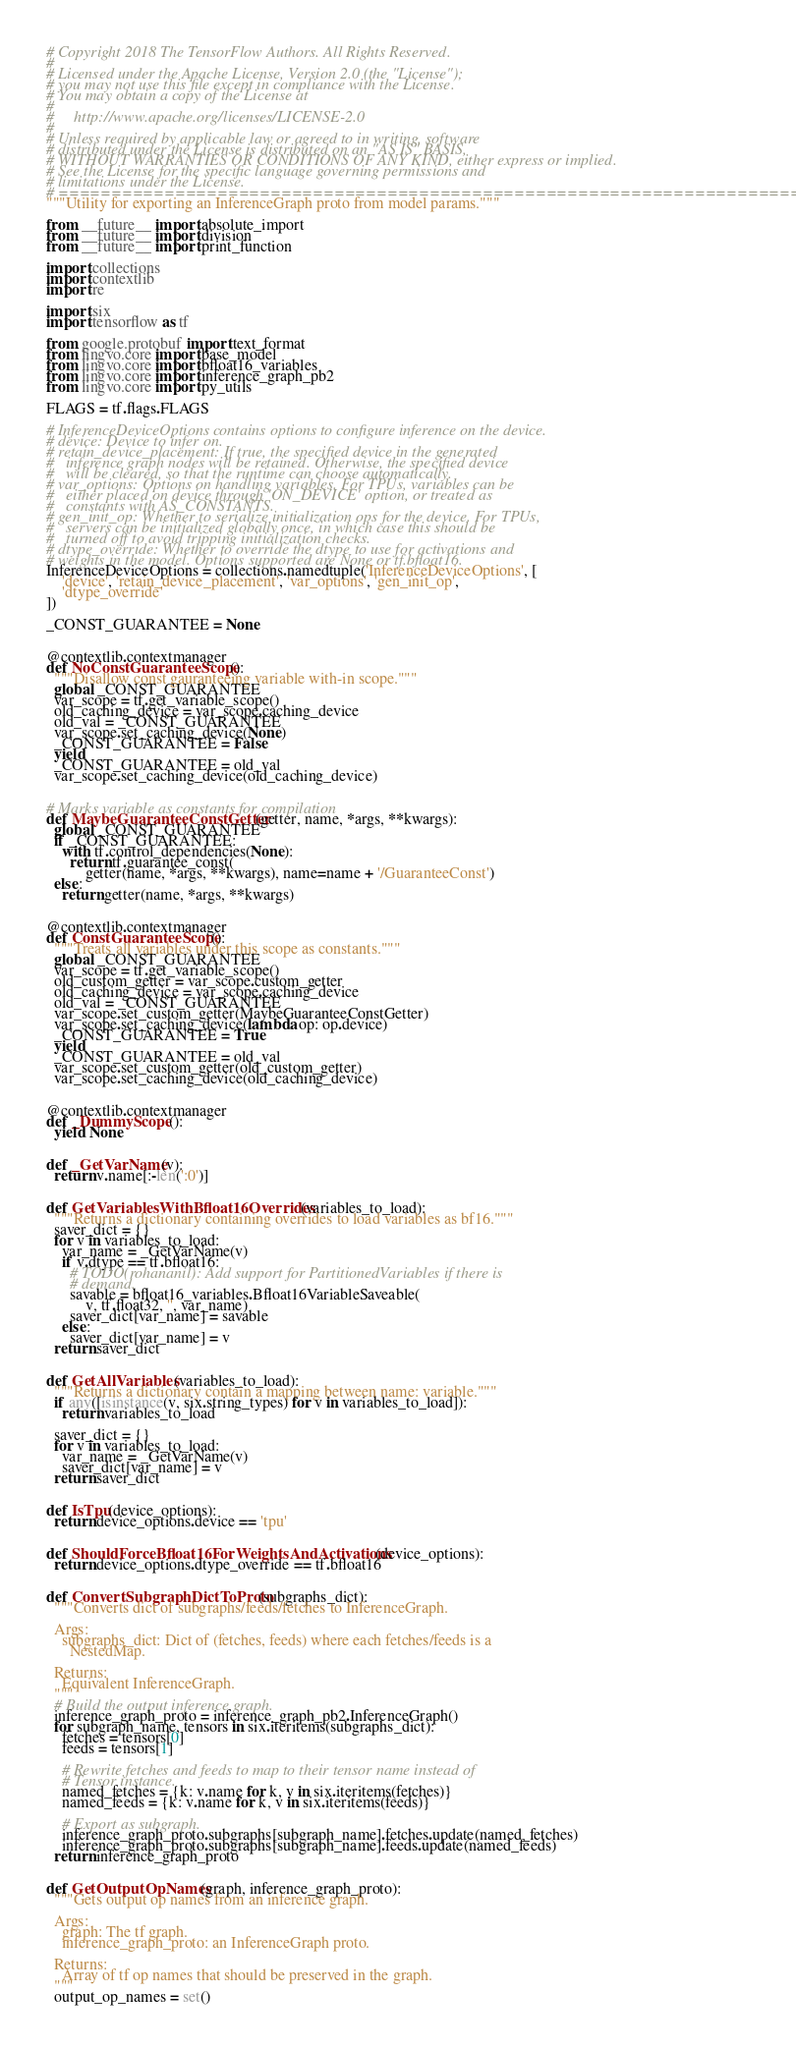<code> <loc_0><loc_0><loc_500><loc_500><_Python_># Copyright 2018 The TensorFlow Authors. All Rights Reserved.
#
# Licensed under the Apache License, Version 2.0 (the "License");
# you may not use this file except in compliance with the License.
# You may obtain a copy of the License at
#
#     http://www.apache.org/licenses/LICENSE-2.0
#
# Unless required by applicable law or agreed to in writing, software
# distributed under the License is distributed on an "AS IS" BASIS,
# WITHOUT WARRANTIES OR CONDITIONS OF ANY KIND, either express or implied.
# See the License for the specific language governing permissions and
# limitations under the License.
# ==============================================================================
"""Utility for exporting an InferenceGraph proto from model params."""

from __future__ import absolute_import
from __future__ import division
from __future__ import print_function

import collections
import contextlib
import re

import six
import tensorflow as tf

from google.protobuf import text_format
from lingvo.core import base_model
from lingvo.core import bfloat16_variables
from lingvo.core import inference_graph_pb2
from lingvo.core import py_utils

FLAGS = tf.flags.FLAGS

# InferenceDeviceOptions contains options to configure inference on the device.
# device: Device to infer on.
# retain_device_placement: If true, the specified device in the generated
#   inference graph nodes will be retained. Otherwise, the specified device
#   will be cleared, so that the runtime can choose automatically.
# var_options: Options on handling variables. For TPUs, variables can be
#   either placed on device through 'ON_DEVICE' option, or treated as
#   constants with AS_CONSTANTS.
# gen_init_op: Whether to serialize initialization ops for the device. For TPUs,
#   servers can be initialized globally once, in which case this should be
#   turned off to avoid tripping initialization checks.
# dtype_override: Whether to override the dtype to use for activations and
# weights in the model. Options supported are None or tf.bfloat16.
InferenceDeviceOptions = collections.namedtuple('InferenceDeviceOptions', [
    'device', 'retain_device_placement', 'var_options', 'gen_init_op',
    'dtype_override'
])

_CONST_GUARANTEE = None


@contextlib.contextmanager
def NoConstGuaranteeScope():
  """Disallow const gauranteeing variable with-in scope."""
  global _CONST_GUARANTEE
  var_scope = tf.get_variable_scope()
  old_caching_device = var_scope.caching_device
  old_val = _CONST_GUARANTEE
  var_scope.set_caching_device(None)
  _CONST_GUARANTEE = False
  yield
  _CONST_GUARANTEE = old_val
  var_scope.set_caching_device(old_caching_device)


# Marks variable as constants for compilation
def MaybeGuaranteeConstGetter(getter, name, *args, **kwargs):
  global _CONST_GUARANTEE
  if _CONST_GUARANTEE:
    with tf.control_dependencies(None):
      return tf.guarantee_const(
          getter(name, *args, **kwargs), name=name + '/GuaranteeConst')
  else:
    return getter(name, *args, **kwargs)


@contextlib.contextmanager
def ConstGuaranteeScope():
  """Treats all variables under this scope as constants."""
  global _CONST_GUARANTEE
  var_scope = tf.get_variable_scope()
  old_custom_getter = var_scope.custom_getter
  old_caching_device = var_scope.caching_device
  old_val = _CONST_GUARANTEE
  var_scope.set_custom_getter(MaybeGuaranteeConstGetter)
  var_scope.set_caching_device(lambda op: op.device)
  _CONST_GUARANTEE = True
  yield
  _CONST_GUARANTEE = old_val
  var_scope.set_custom_getter(old_custom_getter)
  var_scope.set_caching_device(old_caching_device)


@contextlib.contextmanager
def _DummyScope():
  yield None


def _GetVarName(v):
  return v.name[:-len(':0')]


def GetVariablesWithBfloat16Overrides(variables_to_load):
  """Returns a dictionary containing overrides to load variables as bf16."""
  saver_dict = {}
  for v in variables_to_load:
    var_name = _GetVarName(v)
    if v.dtype == tf.bfloat16:
      # TODO(rohananil): Add support for PartitionedVariables if there is
      # demand.
      savable = bfloat16_variables.Bfloat16VariableSaveable(
          v, tf.float32, '', var_name)
      saver_dict[var_name] = savable
    else:
      saver_dict[var_name] = v
  return saver_dict


def GetAllVariables(variables_to_load):
  """Returns a dictionary contain a mapping between name: variable."""
  if any([isinstance(v, six.string_types) for v in variables_to_load]):
    return variables_to_load

  saver_dict = {}
  for v in variables_to_load:
    var_name = _GetVarName(v)
    saver_dict[var_name] = v
  return saver_dict


def IsTpu(device_options):
  return device_options.device == 'tpu'


def ShouldForceBfloat16ForWeightsAndActivations(device_options):
  return device_options.dtype_override == tf.bfloat16


def ConvertSubgraphDictToProto(subgraphs_dict):
  """Converts dict of subgraphs/feeds/fetches to InferenceGraph.

  Args:
    subgraphs_dict: Dict of (fetches, feeds) where each fetches/feeds is a
      NestedMap.

  Returns:
    Equivalent InferenceGraph.
  """
  # Build the output inference graph.
  inference_graph_proto = inference_graph_pb2.InferenceGraph()
  for subgraph_name, tensors in six.iteritems(subgraphs_dict):
    fetches = tensors[0]
    feeds = tensors[1]

    # Rewrite fetches and feeds to map to their tensor name instead of
    # Tensor instance.
    named_fetches = {k: v.name for k, v in six.iteritems(fetches)}
    named_feeds = {k: v.name for k, v in six.iteritems(feeds)}

    # Export as subgraph.
    inference_graph_proto.subgraphs[subgraph_name].fetches.update(named_fetches)
    inference_graph_proto.subgraphs[subgraph_name].feeds.update(named_feeds)
  return inference_graph_proto


def GetOutputOpNames(graph, inference_graph_proto):
  """Gets output op names from an inference graph.

  Args:
    graph: The tf graph.
    inference_graph_proto: an InferenceGraph proto.

  Returns:
    Array of tf op names that should be preserved in the graph.
  """
  output_op_names = set()</code> 